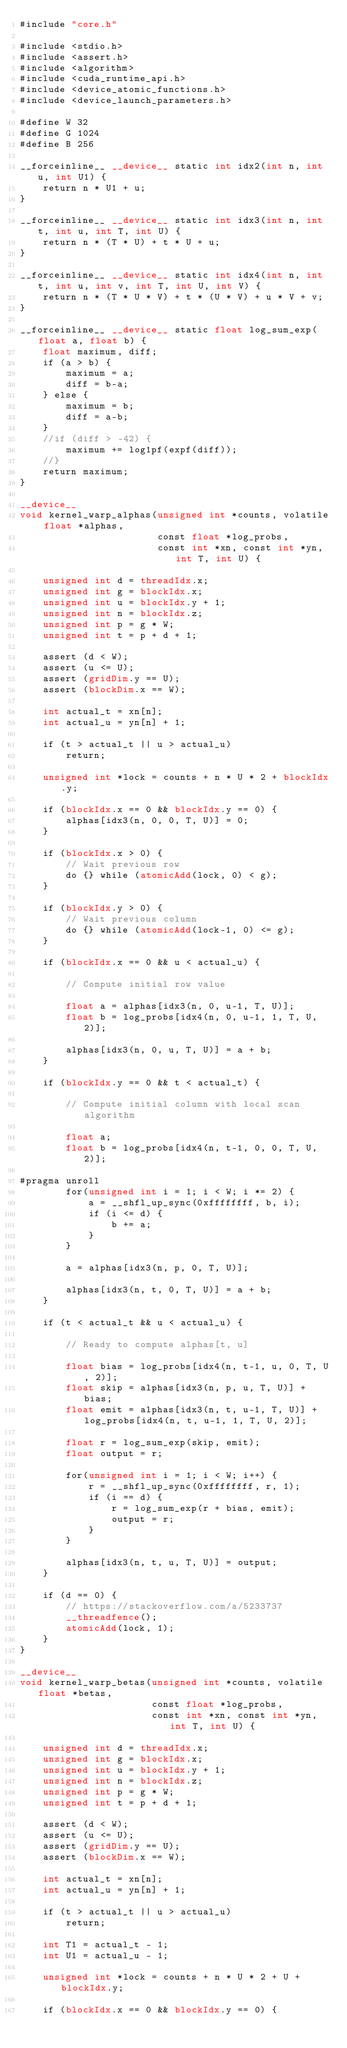Convert code to text. <code><loc_0><loc_0><loc_500><loc_500><_Cuda_>#include "core.h"

#include <stdio.h>
#include <assert.h>
#include <algorithm>
#include <cuda_runtime_api.h>
#include <device_atomic_functions.h>
#include <device_launch_parameters.h>

#define W 32
#define G 1024
#define B 256

__forceinline__ __device__ static int idx2(int n, int u, int U1) {
    return n * U1 + u;
}

__forceinline__ __device__ static int idx3(int n, int t, int u, int T, int U) {
    return n * (T * U) + t * U + u;
}

__forceinline__ __device__ static int idx4(int n, int t, int u, int v, int T, int U, int V) {
    return n * (T * U * V) + t * (U * V) + u * V + v;
}

__forceinline__ __device__ static float log_sum_exp(float a, float b) {
    float maximum, diff;
    if (a > b) {
        maximum = a;
        diff = b-a;
    } else {
        maximum = b;
        diff = a-b;
    }
    //if (diff > -42) {
        maximum += log1pf(expf(diff));
    //}
    return maximum;
}

__device__
void kernel_warp_alphas(unsigned int *counts, volatile float *alphas,
                        const float *log_probs,
                        const int *xn, const int *yn, int T, int U) {

    unsigned int d = threadIdx.x;
    unsigned int g = blockIdx.x;
    unsigned int u = blockIdx.y + 1;
    unsigned int n = blockIdx.z;
    unsigned int p = g * W;
    unsigned int t = p + d + 1;

    assert (d < W);
    assert (u <= U);
    assert (gridDim.y == U);
    assert (blockDim.x == W);

    int actual_t = xn[n];
    int actual_u = yn[n] + 1;

    if (t > actual_t || u > actual_u)
        return;

    unsigned int *lock = counts + n * U * 2 + blockIdx.y;

    if (blockIdx.x == 0 && blockIdx.y == 0) {
        alphas[idx3(n, 0, 0, T, U)] = 0;
    }

    if (blockIdx.x > 0) {
        // Wait previous row
        do {} while (atomicAdd(lock, 0) < g);
    }

    if (blockIdx.y > 0) {
        // Wait previous column
        do {} while (atomicAdd(lock-1, 0) <= g);
    }

    if (blockIdx.x == 0 && u < actual_u) {

        // Compute initial row value

        float a = alphas[idx3(n, 0, u-1, T, U)];
        float b = log_probs[idx4(n, 0, u-1, 1, T, U, 2)];

        alphas[idx3(n, 0, u, T, U)] = a + b;
    }

    if (blockIdx.y == 0 && t < actual_t) {

        // Compute initial column with local scan algorithm

        float a;
        float b = log_probs[idx4(n, t-1, 0, 0, T, U, 2)];

#pragma unroll
        for(unsigned int i = 1; i < W; i *= 2) {
            a = __shfl_up_sync(0xffffffff, b, i);
            if (i <= d) {
                b += a;
            }
        }

        a = alphas[idx3(n, p, 0, T, U)];

        alphas[idx3(n, t, 0, T, U)] = a + b;
    }

    if (t < actual_t && u < actual_u) {

        // Ready to compute alphas[t, u]

        float bias = log_probs[idx4(n, t-1, u, 0, T, U, 2)];
        float skip = alphas[idx3(n, p, u, T, U)] + bias;
        float emit = alphas[idx3(n, t, u-1, T, U)] + log_probs[idx4(n, t, u-1, 1, T, U, 2)];

        float r = log_sum_exp(skip, emit);
        float output = r;

        for(unsigned int i = 1; i < W; i++) {
            r = __shfl_up_sync(0xffffffff, r, 1);
            if (i == d) {
                r = log_sum_exp(r + bias, emit);
                output = r;
            }
        }

        alphas[idx3(n, t, u, T, U)] = output;
    }

    if (d == 0) {
        // https://stackoverflow.com/a/5233737
        __threadfence();
        atomicAdd(lock, 1);
    }
}

__device__
void kernel_warp_betas(unsigned int *counts, volatile float *betas,
                       const float *log_probs,
                       const int *xn, const int *yn, int T, int U) {

    unsigned int d = threadIdx.x;
    unsigned int g = blockIdx.x;
    unsigned int u = blockIdx.y + 1;
    unsigned int n = blockIdx.z;
    unsigned int p = g * W;
    unsigned int t = p + d + 1;

    assert (d < W);
    assert (u <= U);
    assert (gridDim.y == U);
    assert (blockDim.x == W);

    int actual_t = xn[n];
    int actual_u = yn[n] + 1;

    if (t > actual_t || u > actual_u)
        return;

    int T1 = actual_t - 1;
    int U1 = actual_u - 1;

    unsigned int *lock = counts + n * U * 2 + U + blockIdx.y;

    if (blockIdx.x == 0 && blockIdx.y == 0) {</code> 